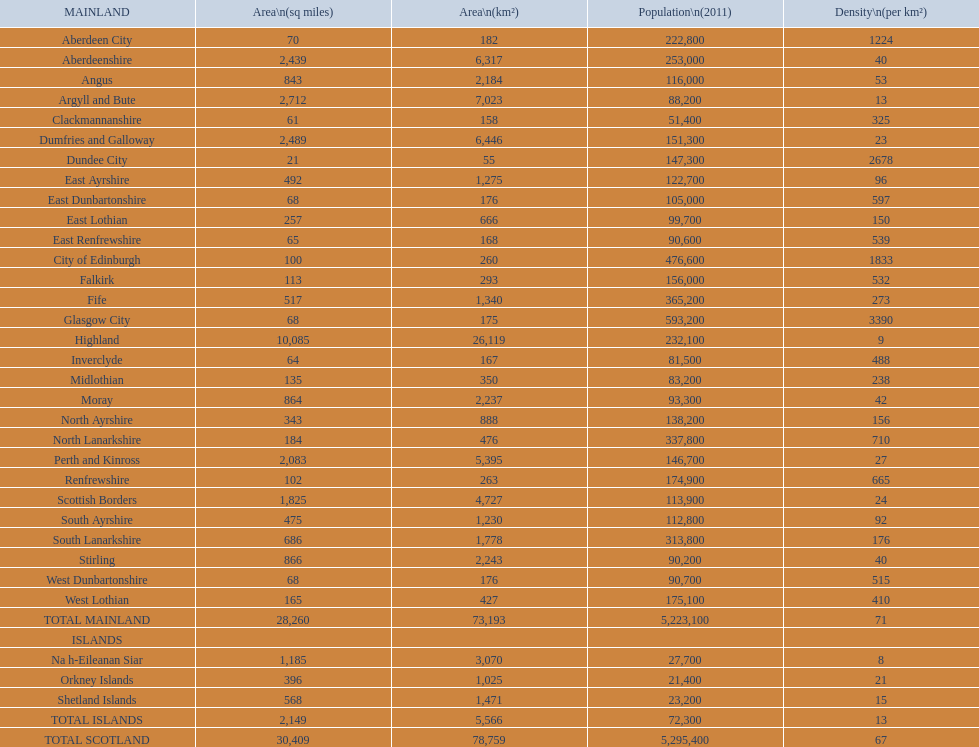What is the total area of east lothian, angus, and dundee city? 1121. 